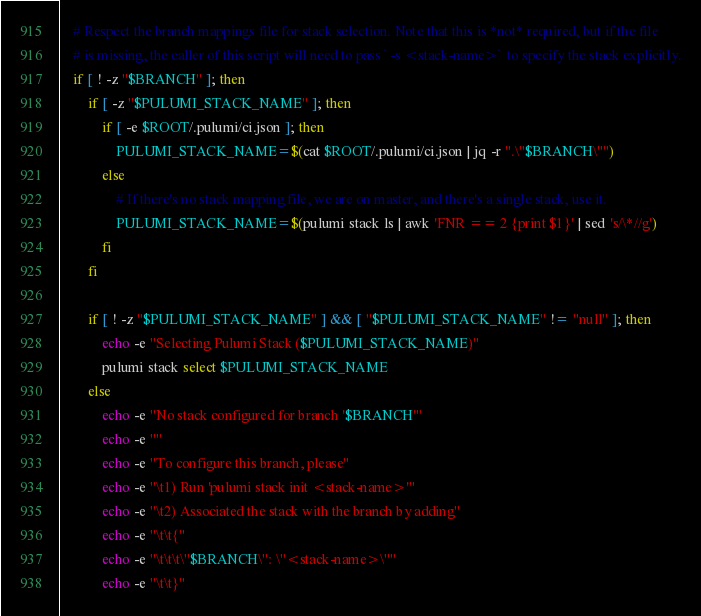<code> <loc_0><loc_0><loc_500><loc_500><_Bash_>    # Respect the branch mappings file for stack selection. Note that this is *not* required, but if the file
    # is missing, the caller of this script will need to pass `-s <stack-name>` to specify the stack explicitly.
    if [ ! -z "$BRANCH" ]; then
        if [ -z "$PULUMI_STACK_NAME" ]; then
            if [ -e $ROOT/.pulumi/ci.json ]; then
                PULUMI_STACK_NAME=$(cat $ROOT/.pulumi/ci.json | jq -r ".\"$BRANCH\"")
            else
                # If there's no stack mapping file, we are on master, and there's a single stack, use it.
                PULUMI_STACK_NAME=$(pulumi stack ls | awk 'FNR == 2 {print $1}' | sed 's/\*//g')
            fi
        fi

        if [ ! -z "$PULUMI_STACK_NAME" ] && [ "$PULUMI_STACK_NAME" != "null" ]; then
            echo -e "Selecting Pulumi Stack ($PULUMI_STACK_NAME)"
            pulumi stack select $PULUMI_STACK_NAME
        else
            echo -e "No stack configured for branch '$BRANCH'"
            echo -e ""
            echo -e "To configure this branch, please"
            echo -e "\t1) Run 'pulumi stack init <stack-name>'"
            echo -e "\t2) Associated the stack with the branch by adding"
            echo -e "\t\t{"
            echo -e "\t\t\t\"$BRANCH\": \"<stack-name>\""
            echo -e "\t\t}"</code> 